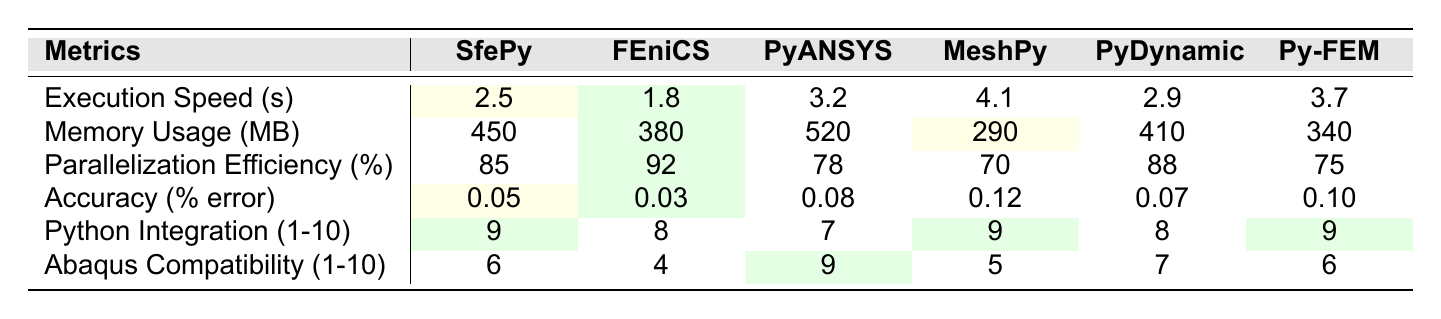What is the execution speed of FEniCS? From the table, the execution speed for FEniCS is listed directly under its column as 1.8 seconds.
Answer: 1.8 seconds Which library has the lowest memory usage? By examining the memory usage row, the lowest value is noted for MeshPy at 290 MB.
Answer: MeshPy What is the accuracy percentage for PyANSYS? The accuracy percentage for PyANSYS is presented in the accuracy row as 0.08% error.
Answer: 0.08% error Is SfePy the fastest library based on execution speed? Comparing execution speeds, SfePy has a speed of 2.5 seconds, which is slower than FEniCS (1.8 seconds). Therefore, SfePy is not the fastest.
Answer: No What is the average parallelization efficiency of all libraries? To find the average, add all values: (85 + 92 + 78 + 70 + 88 + 75) = 508, then divide by the number of libraries (6): 508/6 ≈ 84.67%.
Answer: 84.67% How does the Abaqus compatibility of PyDynamic compare to that of FEniCS? The Abaqus compatibility for PyDynamic is 7, while for FEniCS it is 4. Since 7 is greater than 4, PyDynamic is more compatible.
Answer: PyDynamic is more compatible Which library has the best execution speed and what is the value? By checking the execution speed row, FEniCS has the best speed of 1.8 seconds (the lowest), so it holds the best performance in this metric.
Answer: 1.8 seconds What library has the highest memory usage? The memory usage values show that PyANSYS has the highest usage at 520 MB, as it is the greatest number in that row.
Answer: PyANSYS Is there a library that has an accuracy error of less than 0.07%? Reviewing the accuracy error values, only SfePy and FEniCS have accuracy errors below 0.07%, as SfePy has 0.05% and FEniCS has 0.03%.
Answer: Yes Which library has the highest parallelization efficiency and what is the value? The highest parallelization efficiency belongs to FEniCS, with an efficiency of 92%, making it the top performer in this metric.
Answer: 92% What is the difference in execution speed between SfePy and MeshPy? To find the difference, subtract MeshPy's execution speed (4.1 seconds) from SfePy's (2.5 seconds): 2.5 - 4.1 = -1.6 seconds, so SfePy is faster by this amount.
Answer: -1.6 seconds 